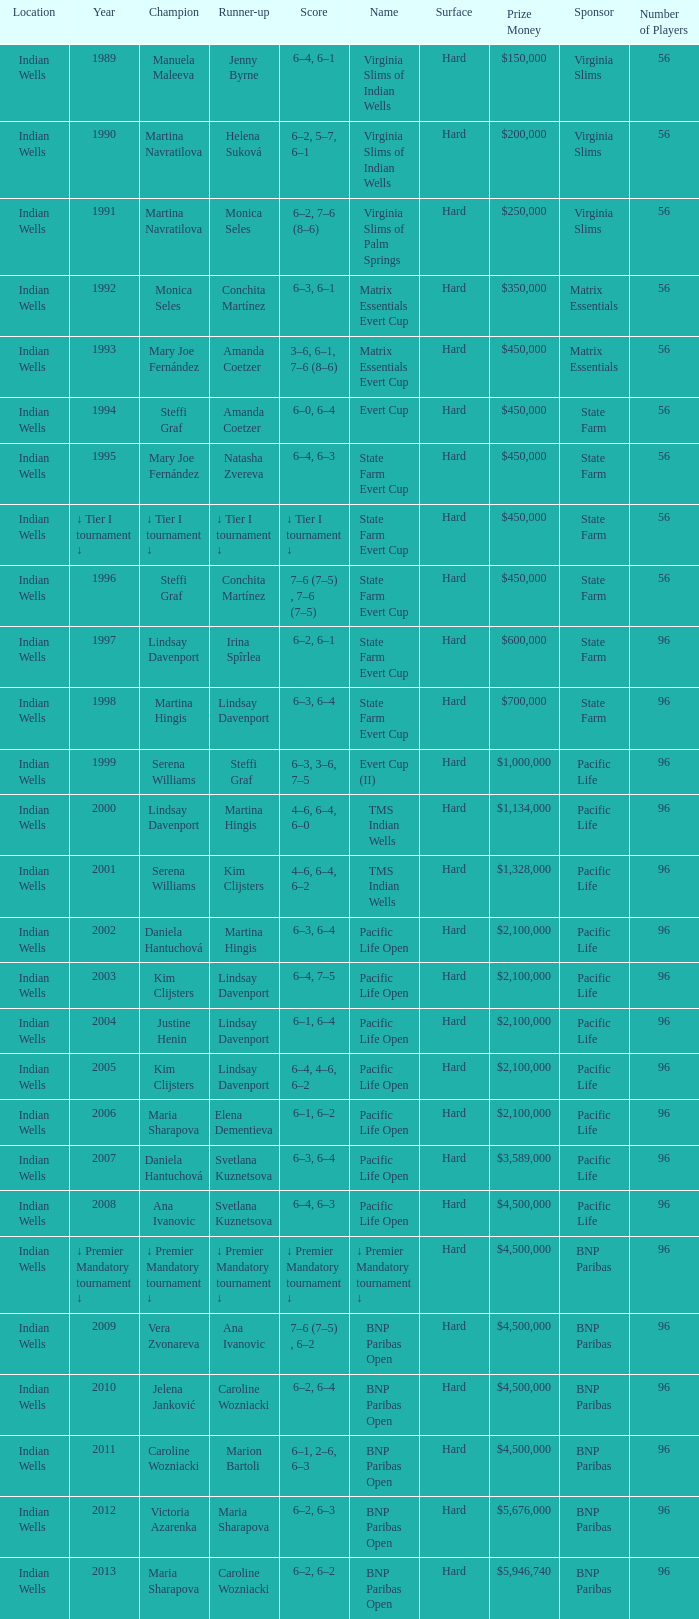Who was runner-up in the 2006 Pacific Life Open? Elena Dementieva. 